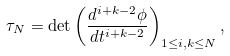Convert formula to latex. <formula><loc_0><loc_0><loc_500><loc_500>\tau _ { N } = \det \left ( \frac { d ^ { i + k - 2 } \phi } { d t ^ { i + k - 2 } } \right ) _ { 1 \leq i , k \leq N } ,</formula> 